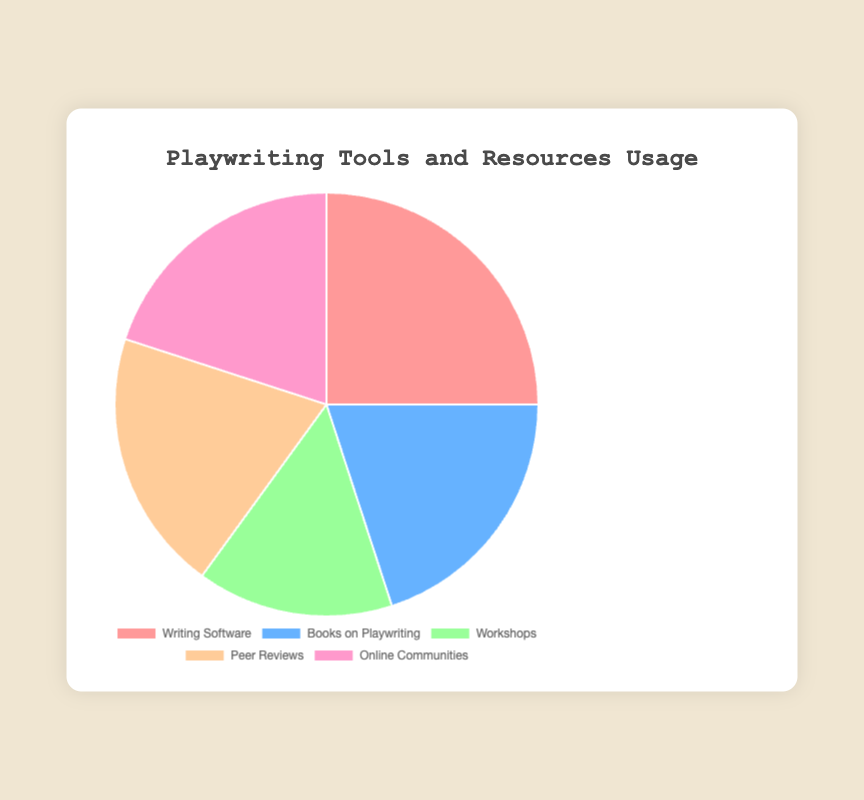What proportion of the data points represent resources used by 20% of respondents? There are three data points: "Books on Playwriting," "Peer Reviews," and "Online Communities," each with a percentage of 20. These sum up to 60%.
Answer: 60% What is the difference in usage percentage between the most and least used resources? The most used resource is "Writing Software" at 25%, and the least used is "Workshops" at 15%. The difference is 25% - 15% = 10%.
Answer: 10% Which resource is equally used by the same percentage of respondents? "Books on Playwriting," "Peer Reviews," and "Online Communities" each have the same percentage use of 20%.
Answer: "Books on Playwriting," "Peer Reviews," and "Online Communities" Which segment in the pie chart represents the largest portion, and what is its color? The largest portion is represented by "Writing Software," which occupies 25% of the chart, and its color is pink.
Answer: "Writing Software," pink How is the percentage of respondents who use "Workshops" compared to those who use "Books on Playwriting"? "Workshops" are used by 15% of respondents, while "Books on Playwriting" are used by 20%. Hence, "Workshops" are used 5% less.
Answer: 5% less What is the combined percentage usage of the least three adopted resources? The least three adopted resources are "Books on Playwriting," "Workshops," and "Online Communities," with percentages 20%, 15%, and 20% respectively. The combined percentage is 20% + 15% + 20% = 55%.
Answer: 55% What would be the average usage percentage if "Writing Software" and "Peer Reviews" were grouped together? The percentage for "Writing Software" is 25% and for "Peer Reviews" is 20%. The average would be (25% + 20%)/2 = 22.5%.
Answer: 22.5% If we combine "Books on Playwriting" and "Online Communities," what is their total usage percentage? The percentage for "Books on Playwriting" is 20% and "Online Communities" is 20%. So, their combined total is 20% + 20% = 40%.
Answer: 40% What's the ratio of usage between "Writing Software" and "Workshops"? "Writing Software" is used by 25%, and "Workshops" by 15%. The ratio is 25% / 15% = 5/3 or approximately 1.67.
Answer: 5:3 or 1.67 Which two segments together make up exactly 40% of the pie chart? Both "Books on Playwriting" and "Online Communities," each with a percentage of 20%, together make up 40% of the chart.
Answer: "Books on Playwriting" and "Online Communities" 